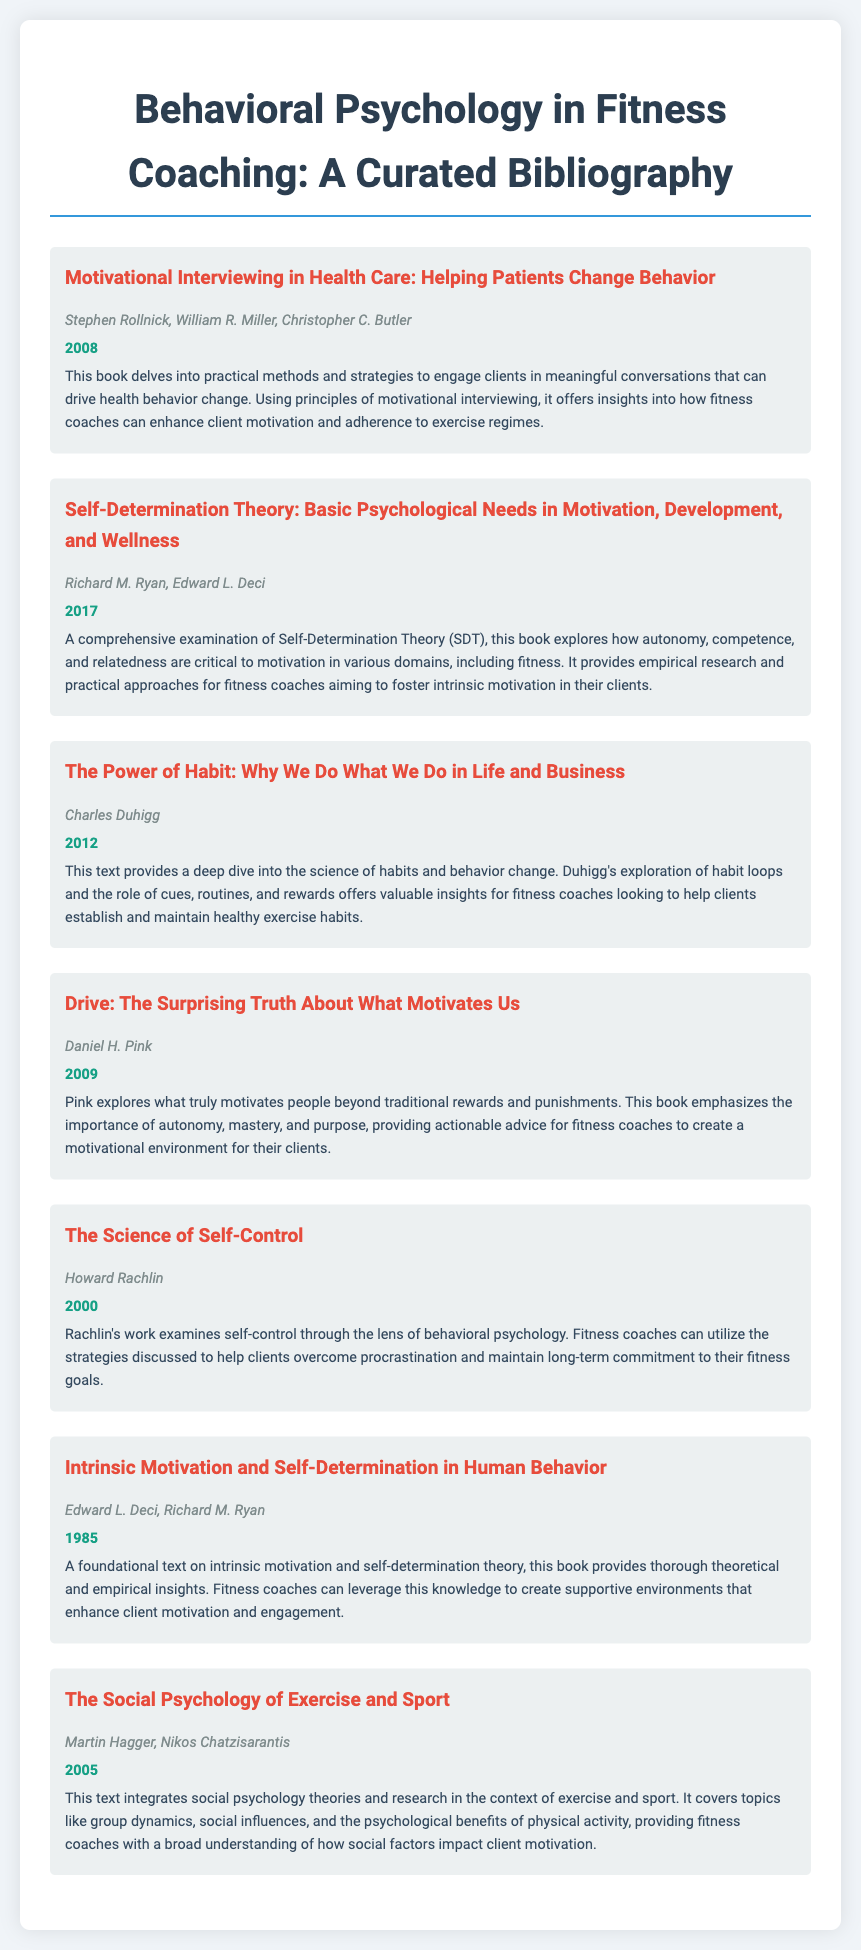What is the title of the first item in the bibliography? The title of the first item is presented in the document as the first bibliographic entry, which is focused on motivational interviewing.
Answer: Motivational Interviewing in Health Care: Helping Patients Change Behavior Who are the authors of "The Power of Habit"? This question pertains to the authors listed for "The Power of Habit" in the document, specifically their names.
Answer: Charles Duhigg What year was "Drive: The Surprising Truth About What Motivates Us" published? The publication year for "Drive" is provided directly in the bibliographic entry for this work.
Answer: 2009 Which psychological theory is explored in "Self-Determination Theory: Basic Psychological Needs in Motivation, Development, and Wellness"? This question examines the primary focus of the second item in the bibliography, identifying the specific psychological framework discussed.
Answer: Self-Determination Theory What is the main theme of "The Science of Self-Control"? This relates to the central concept addressed in Rachlin's work as described in the document, focusing on self-control from a psychological perspective.
Answer: Self-control How many items are included in the bibliography? This information is inferred from the count of bibliography items within the provided document's structure, specifically their individual presentations.
Answer: 7 What is a key element that "Drive" emphasizes as a motivator? This question highlights the essential motivational factors mentioned in Daniel H. Pink's work accessible through the bibliography, focusing on its take on motivation.
Answer: Autonomy What role does social psychology play according to "The Social Psychology of Exercise and Sport"? This examines the context in which social psychology is integrated as discussed in this specific entry of the bibliography, covering its impact on exercise behavior.
Answer: Exercise and sport 